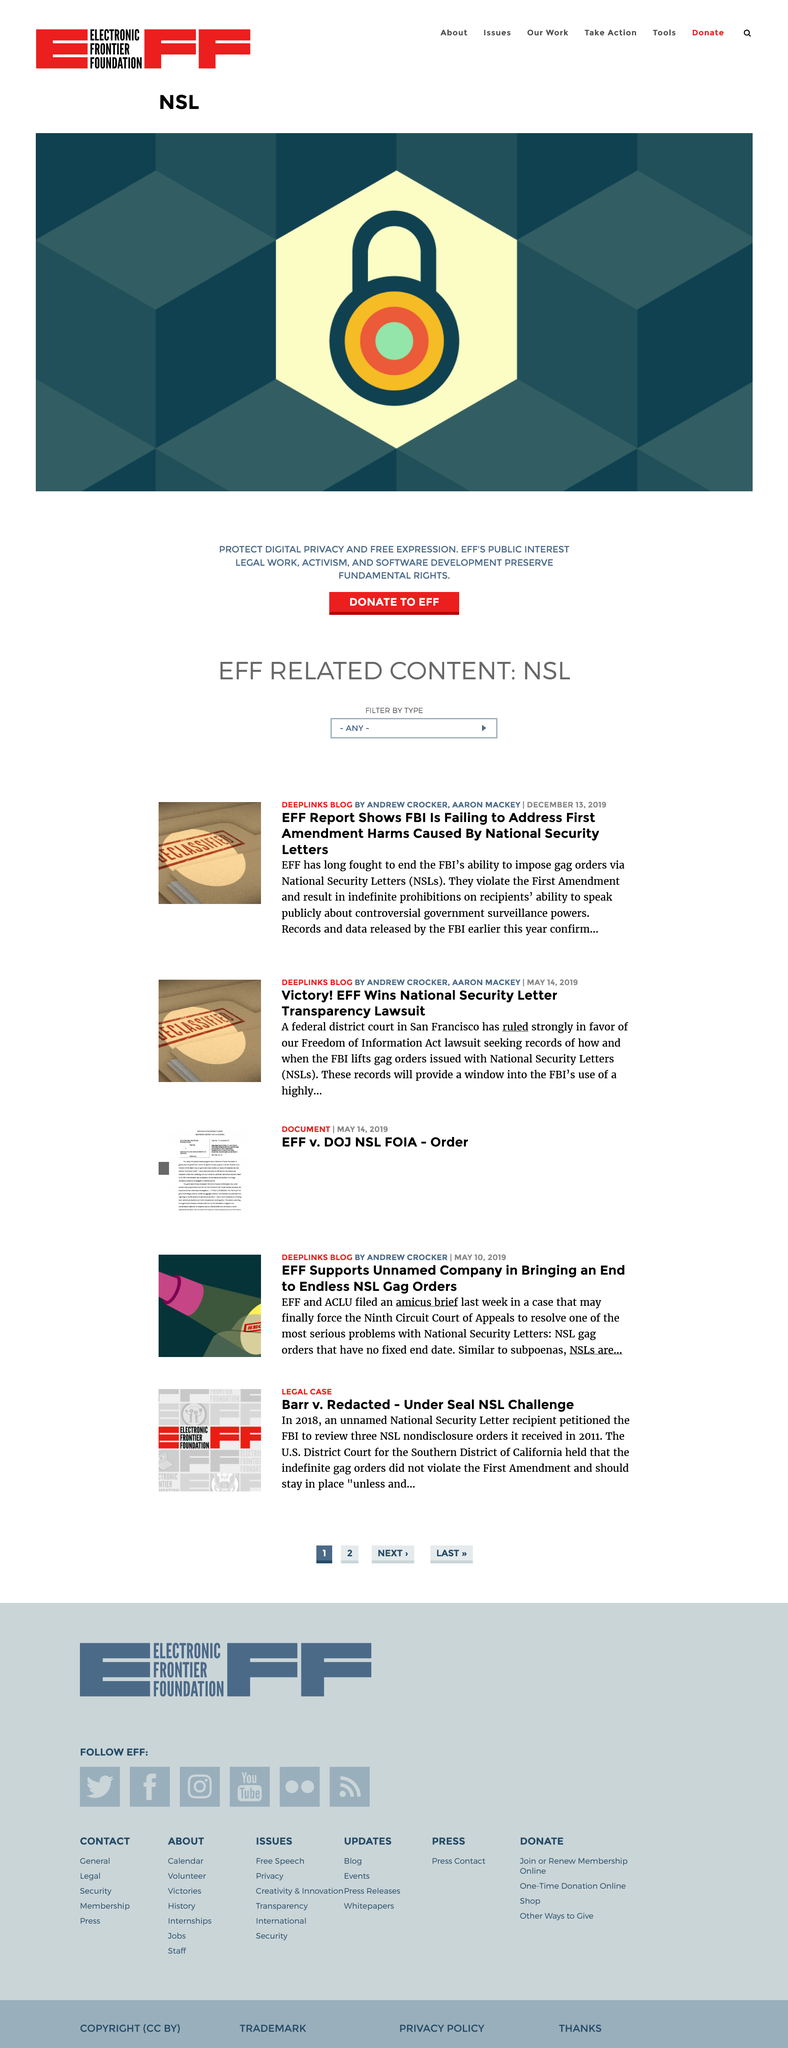Draw attention to some important aspects in this diagram. In 2018, the FBI was petitioned to review National Security Letter nondisclosure orders that were issued in 2011. National Security Letters are a tool used by law enforcement agencies in the United States to request information from individuals and organizations without having to obtain a warrant. Andrew Crocker, as stated by the Electronic Frontier Foundation (EFF), aims to bring an end to the issuance of endless National Security Letters (NSLs) accompanied by gag orders that restrict free speech and undermine the principle of accountability. 